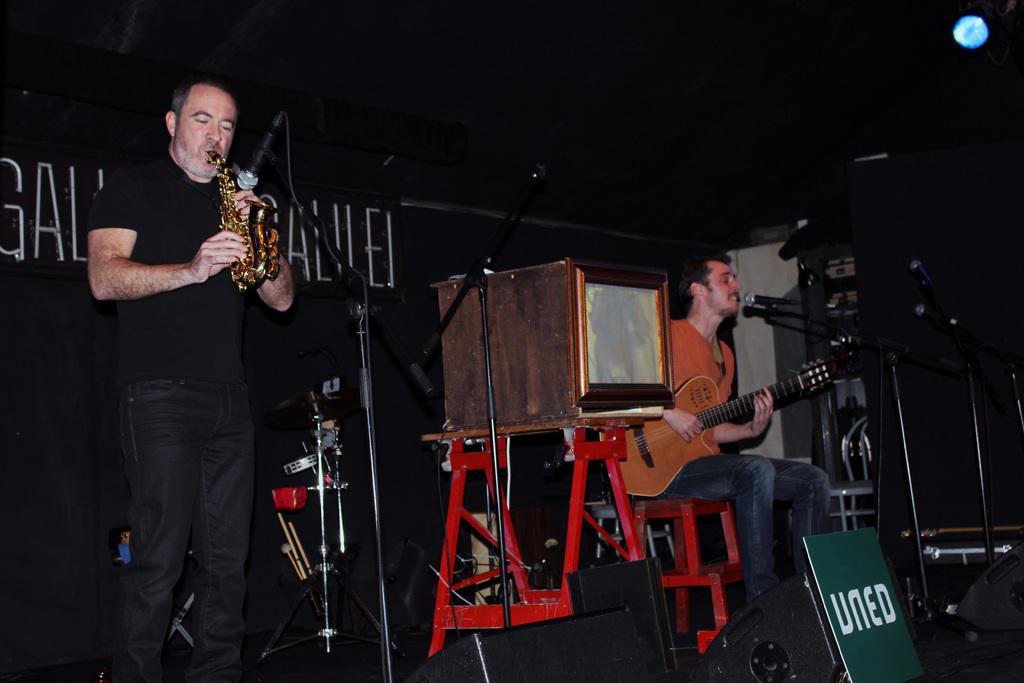Describe this image in one or two sentences. Here we can see a man is standing on the stage and playing saxophone, and in front here is the microphone and stand, and here a man is sitting on the chair and playing the guitar, and here is the table and some object on it. 